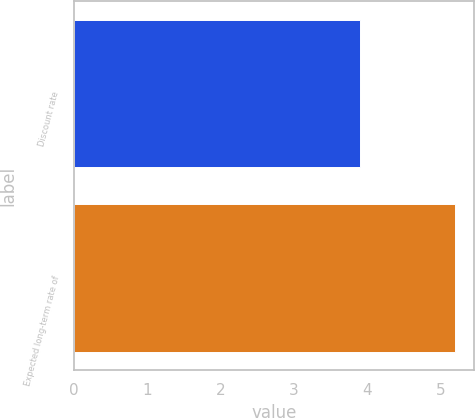Convert chart. <chart><loc_0><loc_0><loc_500><loc_500><bar_chart><fcel>Discount rate<fcel>Expected long-term rate of<nl><fcel>3.9<fcel>5.2<nl></chart> 